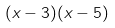<formula> <loc_0><loc_0><loc_500><loc_500>( x - 3 ) ( x - 5 )</formula> 